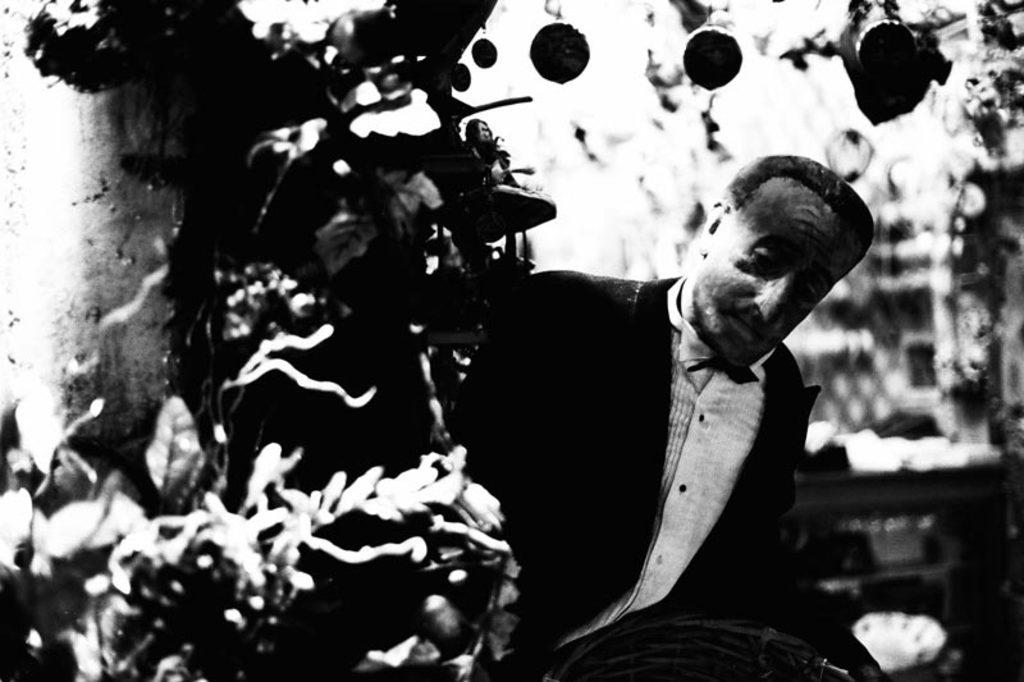What is the color scheme of the image? The image is black and white. Can you describe the main subject in the image? There is a person in the image. What other object is visible in the image? There is a tree in the image. How would you describe the background of the image? The background is blurred. What type of quince can be seen hanging from the tree in the image? There is no quince present in the image; it is a black and white image with a person and a tree. Can you tell me how many forks are visible in the image? There are no forks visible in the image. 